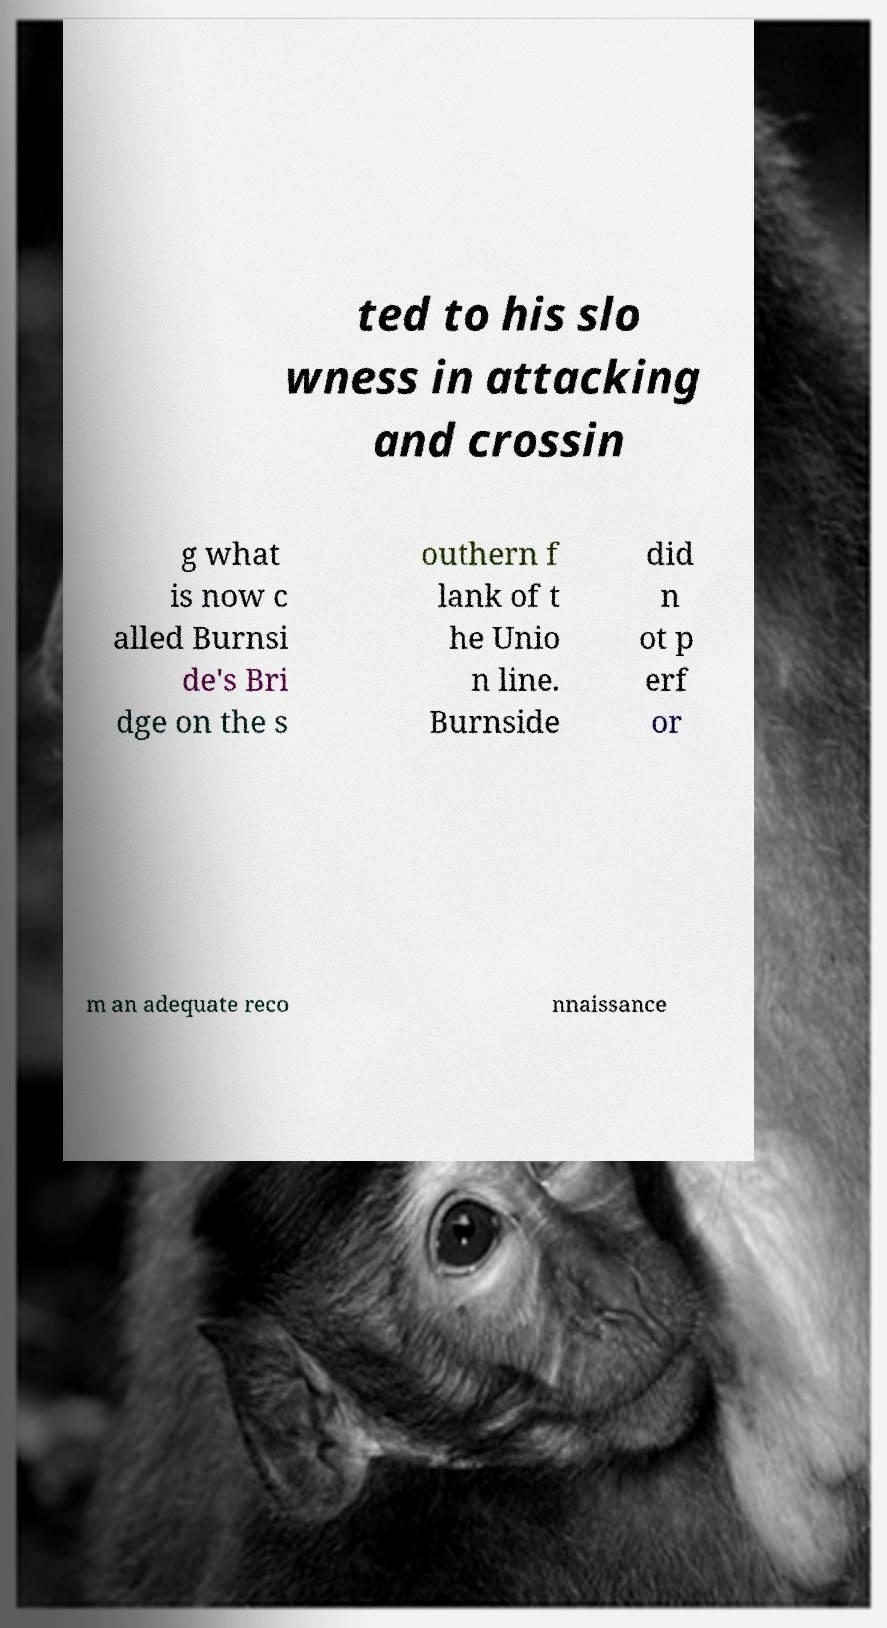Could you extract and type out the text from this image? ted to his slo wness in attacking and crossin g what is now c alled Burnsi de's Bri dge on the s outhern f lank of t he Unio n line. Burnside did n ot p erf or m an adequate reco nnaissance 